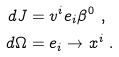Convert formula to latex. <formula><loc_0><loc_0><loc_500><loc_500>d J & = v ^ { i } e _ { i } \beta ^ { 0 } \ , \\ d \Omega & = e _ { i } \to x ^ { i } \ .</formula> 